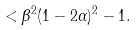Convert formula to latex. <formula><loc_0><loc_0><loc_500><loc_500>< \beta ^ { 2 } ( 1 - 2 \alpha ) ^ { 2 } - 1 .</formula> 